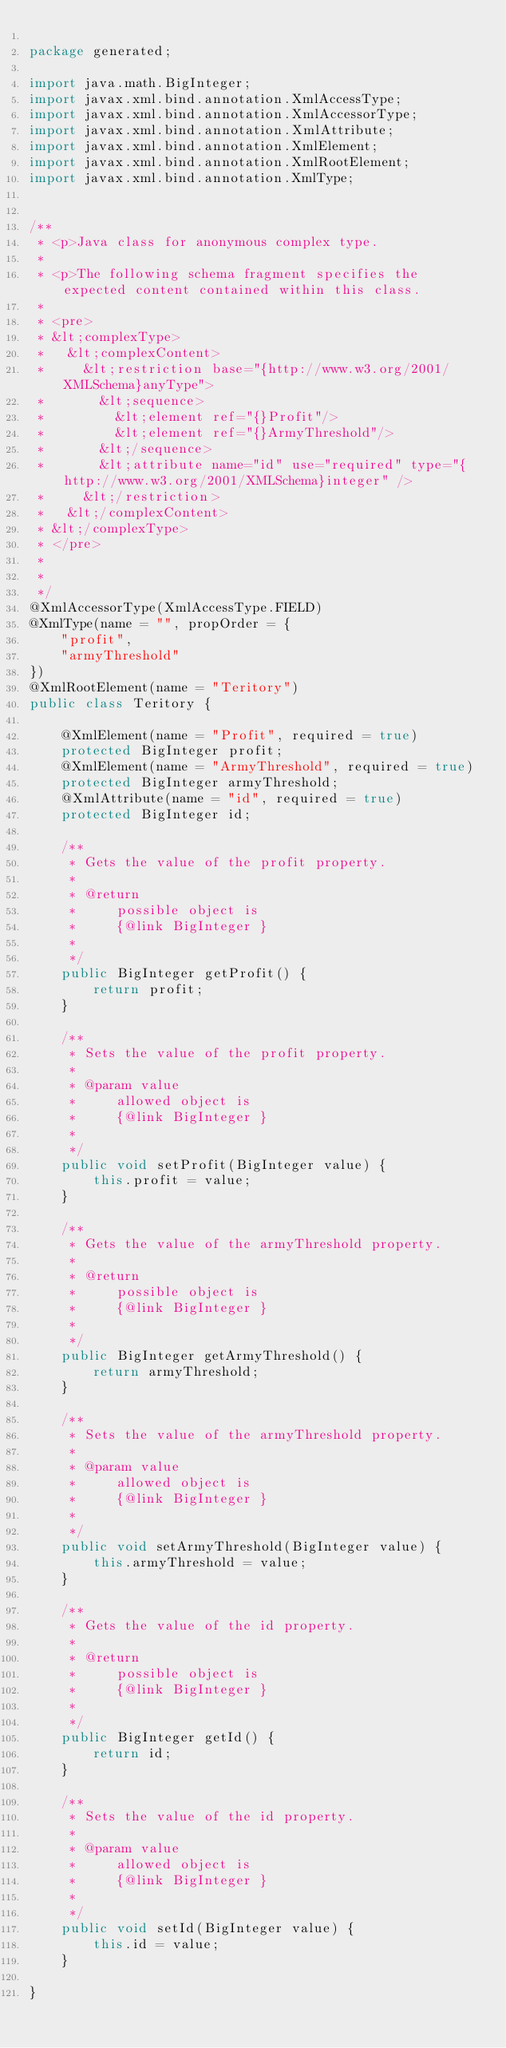Convert code to text. <code><loc_0><loc_0><loc_500><loc_500><_Java_>
package generated;

import java.math.BigInteger;
import javax.xml.bind.annotation.XmlAccessType;
import javax.xml.bind.annotation.XmlAccessorType;
import javax.xml.bind.annotation.XmlAttribute;
import javax.xml.bind.annotation.XmlElement;
import javax.xml.bind.annotation.XmlRootElement;
import javax.xml.bind.annotation.XmlType;


/**
 * <p>Java class for anonymous complex type.
 * 
 * <p>The following schema fragment specifies the expected content contained within this class.
 * 
 * <pre>
 * &lt;complexType>
 *   &lt;complexContent>
 *     &lt;restriction base="{http://www.w3.org/2001/XMLSchema}anyType">
 *       &lt;sequence>
 *         &lt;element ref="{}Profit"/>
 *         &lt;element ref="{}ArmyThreshold"/>
 *       &lt;/sequence>
 *       &lt;attribute name="id" use="required" type="{http://www.w3.org/2001/XMLSchema}integer" />
 *     &lt;/restriction>
 *   &lt;/complexContent>
 * &lt;/complexType>
 * </pre>
 * 
 * 
 */
@XmlAccessorType(XmlAccessType.FIELD)
@XmlType(name = "", propOrder = {
    "profit",
    "armyThreshold"
})
@XmlRootElement(name = "Teritory")
public class Teritory {

    @XmlElement(name = "Profit", required = true)
    protected BigInteger profit;
    @XmlElement(name = "ArmyThreshold", required = true)
    protected BigInteger armyThreshold;
    @XmlAttribute(name = "id", required = true)
    protected BigInteger id;

    /**
     * Gets the value of the profit property.
     * 
     * @return
     *     possible object is
     *     {@link BigInteger }
     *     
     */
    public BigInteger getProfit() {
        return profit;
    }

    /**
     * Sets the value of the profit property.
     * 
     * @param value
     *     allowed object is
     *     {@link BigInteger }
     *     
     */
    public void setProfit(BigInteger value) {
        this.profit = value;
    }

    /**
     * Gets the value of the armyThreshold property.
     * 
     * @return
     *     possible object is
     *     {@link BigInteger }
     *     
     */
    public BigInteger getArmyThreshold() {
        return armyThreshold;
    }

    /**
     * Sets the value of the armyThreshold property.
     * 
     * @param value
     *     allowed object is
     *     {@link BigInteger }
     *     
     */
    public void setArmyThreshold(BigInteger value) {
        this.armyThreshold = value;
    }

    /**
     * Gets the value of the id property.
     * 
     * @return
     *     possible object is
     *     {@link BigInteger }
     *     
     */
    public BigInteger getId() {
        return id;
    }

    /**
     * Sets the value of the id property.
     * 
     * @param value
     *     allowed object is
     *     {@link BigInteger }
     *     
     */
    public void setId(BigInteger value) {
        this.id = value;
    }

}
</code> 